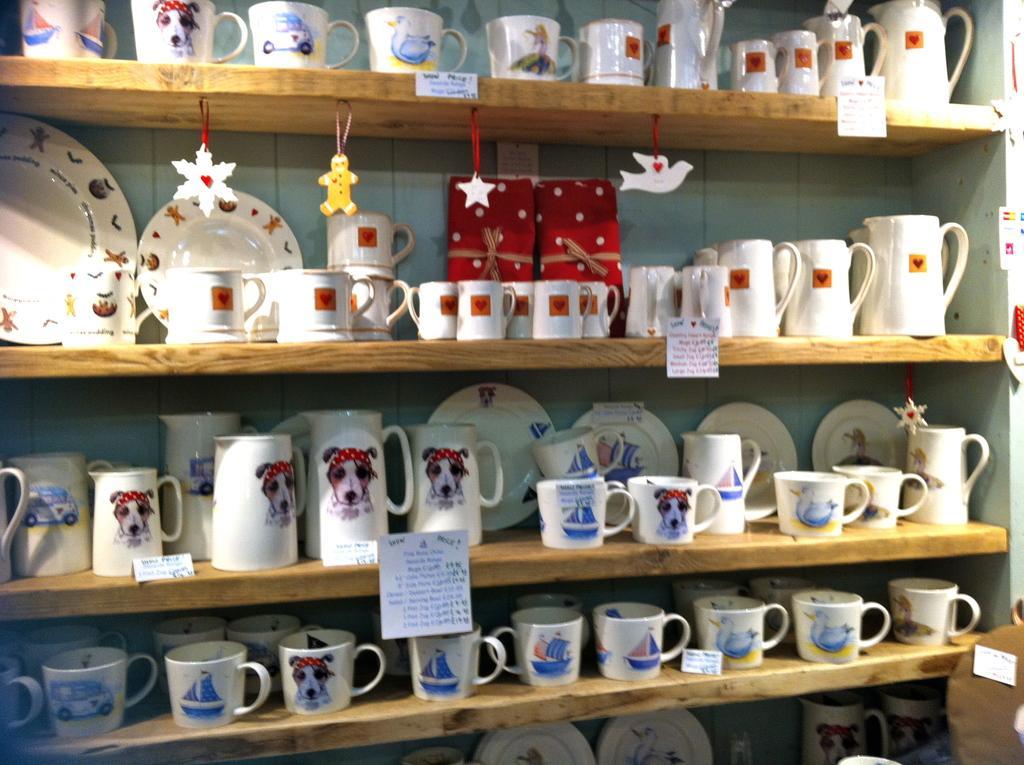Please provide a concise description of this image. In this image I can see there are plates, cups and jugs and other things on the shelves. 